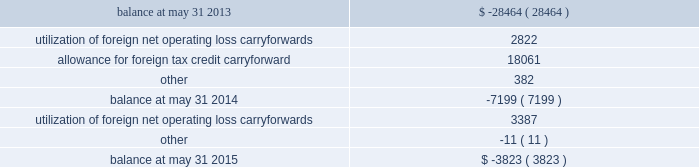Undistributed earnings of $ 696.9 million from certain foreign subsidiaries are considered to be permanently reinvested abroad and will not be repatriated to the united states in the foreseeable future .
Because those earnings are considered to be indefinitely reinvested , no domestic federal or state deferred income taxes have been provided thereon .
If we were to make a distribution of any portion of those earnings in the form of dividends or otherwise , we would be subject to both u.s .
Income taxes ( subject to an adjustment for foreign tax credits ) and withholding taxes payable to the various foreign jurisdictions .
Because of the availability of u.s .
Foreign tax credit carryforwards , it is not practicable to determine the domestic federal income tax liability that would be payable if such earnings were no longer considered to be reinvested indefinitely .
A valuation allowance is provided against deferred tax assets when it is more likely than not that some portion or all of the deferred tax assets will not be realized .
Changes to our valuation allowance during the years ended may 31 , 2015 and 2014 are summarized below ( in thousands ) : .
Net operating loss carryforwards of foreign subsidiaries totaling $ 12.4 million and u.s .
Net operating loss carryforwards previously acquired totaling $ 19.8 million at may 31 , 2015 will expire between may 31 , 2017 and may 31 , 2033 if not utilized .
Capital loss carryforwards of u.s .
Subsidiaries totaling $ 4.7 million will expire if not utilized by may 31 , 2017 .
Tax credit carryforwards totaling $ 8.4 million at may 31 , 2015 will expire between may 31 , 2017 and may 31 , 2023 if not utilized .
We conduct business globally and file income tax returns in the u.s .
Federal jurisdiction and various state and foreign jurisdictions .
In the normal course of business , we are subject to examination by taxing authorities around the world .
As a result of events that occurred in the fourth quarter of the year ended may 31 , 2015 , management concluded that it was more likely than not that the tax positions in a foreign jurisdiction , for which we had recorded estimated liabilities of $ 65.6 million in other noncurrent liabilities on our consolidated balance sheet , would be sustained on their technical merits based on information available as of may 31 , 2015 .
Therefore , the liability and corresponding deferred tax assets were eliminated as of may 31 , 2015 .
The uncertain tax positions have been subject to an ongoing examination in that foreign jurisdiction by the tax authority .
Discussions and correspondence between the tax authority and us during the fourth quarter indicated that the likelihood of the positions being sustained had increased .
Subsequent to may 31 , 2015 , we received a final closure notice regarding the examination resulting in no adjustments to taxable income related to this matter for the tax returns filed for the periods ended may 31 , 2010 through may 31 , 2013 .
The unrecognized tax benefits were effectively settled with this final closure notice .
We are no longer subjected to state income tax examinations for years ended on or before may 31 , 2008 , u.s .
Federal income tax examinations for fiscal years prior to 2012 and united kingdom federal income tax examinations for years ended on or before may 31 , 2013 .
78 2013 global payments inc .
| 2015 form 10-k annual report .
What is the total net operating loss that must be utilized before expiration between may 31 , 2017 and may 31 , 2033? 
Rationale: to calculate the total net operating loss that must be utilized , one must add the foreign subsidiaries net operating loss with the u.s . net operating loss .
Computations: (19.8 + 12.4)
Answer: 32.2. 